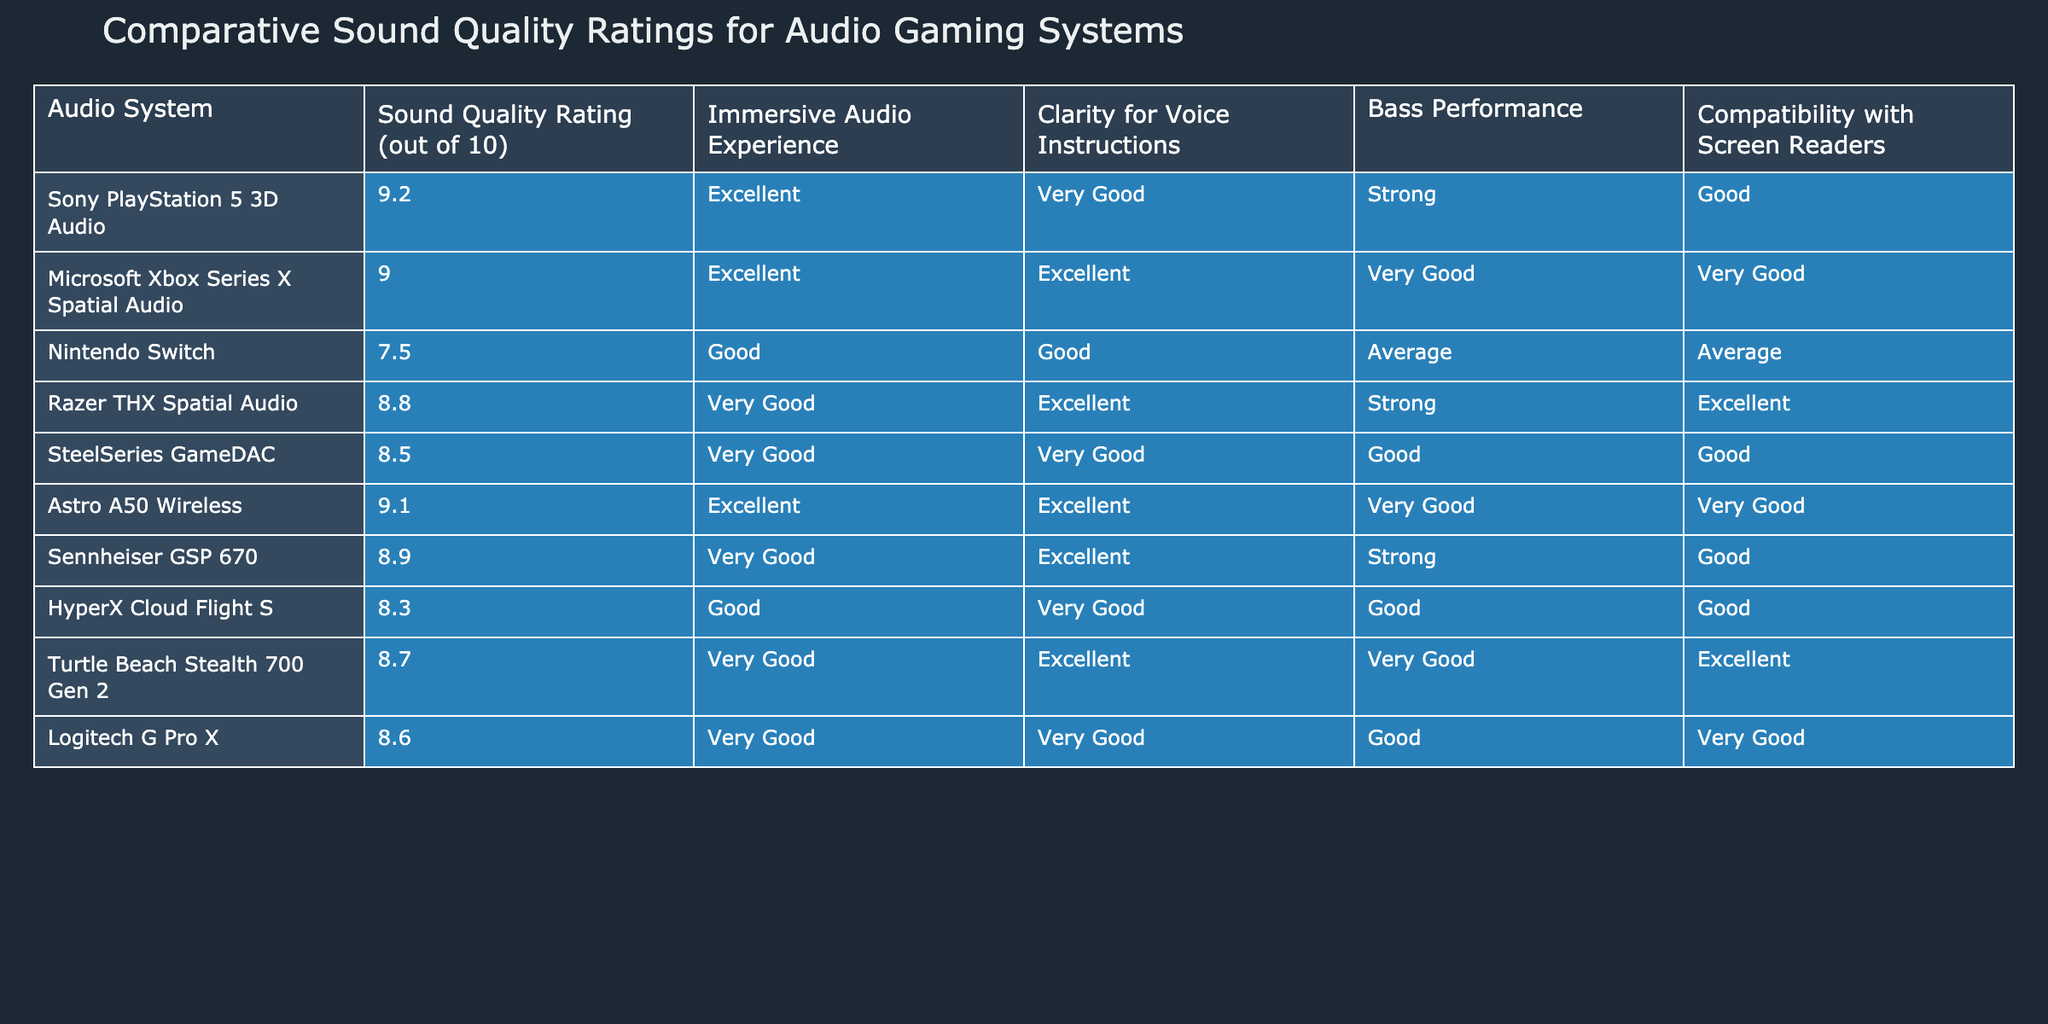What is the sound quality rating for the Sony PlayStation 5 3D Audio? The sound quality rating specifically listed for the Sony PlayStation 5 3D Audio system in the table is 9.2.
Answer: 9.2 Which audio system has the highest sound quality rating? By reviewing the sound quality ratings listed, the Sony PlayStation 5 3D Audio has the highest rating at 9.2.
Answer: Sony PlayStation 5 3D Audio What is the clarity for voice instructions rating of the Razer THX Spatial Audio? Looking at the table, the rating for clarity for voice instructions for the Razer THX Spatial Audio is Excellent.
Answer: Excellent How many audio systems have a sound quality rating of 9 or higher? The systems with ratings of 9 or higher are Sony PlayStation 5, Microsoft Xbox Series X, Astro A50 Wireless, and Razer THX Spatial Audio, totaling 4 systems.
Answer: 4 What is the average sound quality rating of all audio systems listed? The sound quality ratings are 9.2, 9.0, 7.5, 8.8, 8.5, 9.1, 8.9, 8.3, 8.7, and 8.6. Adding them gives a total of 88.6. Dividing by 10 systems gives an average of 8.86.
Answer: 8.86 Which audio system has the strongest bass performance? Inspecting the bass performance ratings, both the Sony PlayStation 5 3D Audio and Razer THX Spatial Audio are noted for Strong bass performance.
Answer: Sony PlayStation 5 3D Audio and Razer THX Spatial Audio Is the Nintendo Switch compatible with screen readers? The table indicates that the compatibility with screen readers for the Nintendo Switch is rated as Average.
Answer: No Which audio system has both excellent clarity for voice instructions and immersive audio experience? The audio systems that have Excellent ratings in both immersive audio experience and clarity for voice instructions are the Sony PlayStation 5 3D Audio and Astro A50 Wireless.
Answer: Sony PlayStation 5 3D Audio and Astro A50 Wireless Do any audio systems score excellent for both immersive audio experience and bass performance? Reviewing the table, the only system that scores Excellent for immersive audio experience but does not have a Strong bass rating is the Razer THX Spatial Audio; thus, no systems meet both criteria.
Answer: No 